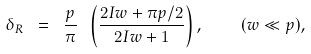<formula> <loc_0><loc_0><loc_500><loc_500>\delta _ { R } \ = \ \frac { p } { \pi } \ \left ( \frac { 2 I w + \pi p / 2 } { 2 I w + 1 } \right ) , \quad ( w \ll p ) ,</formula> 